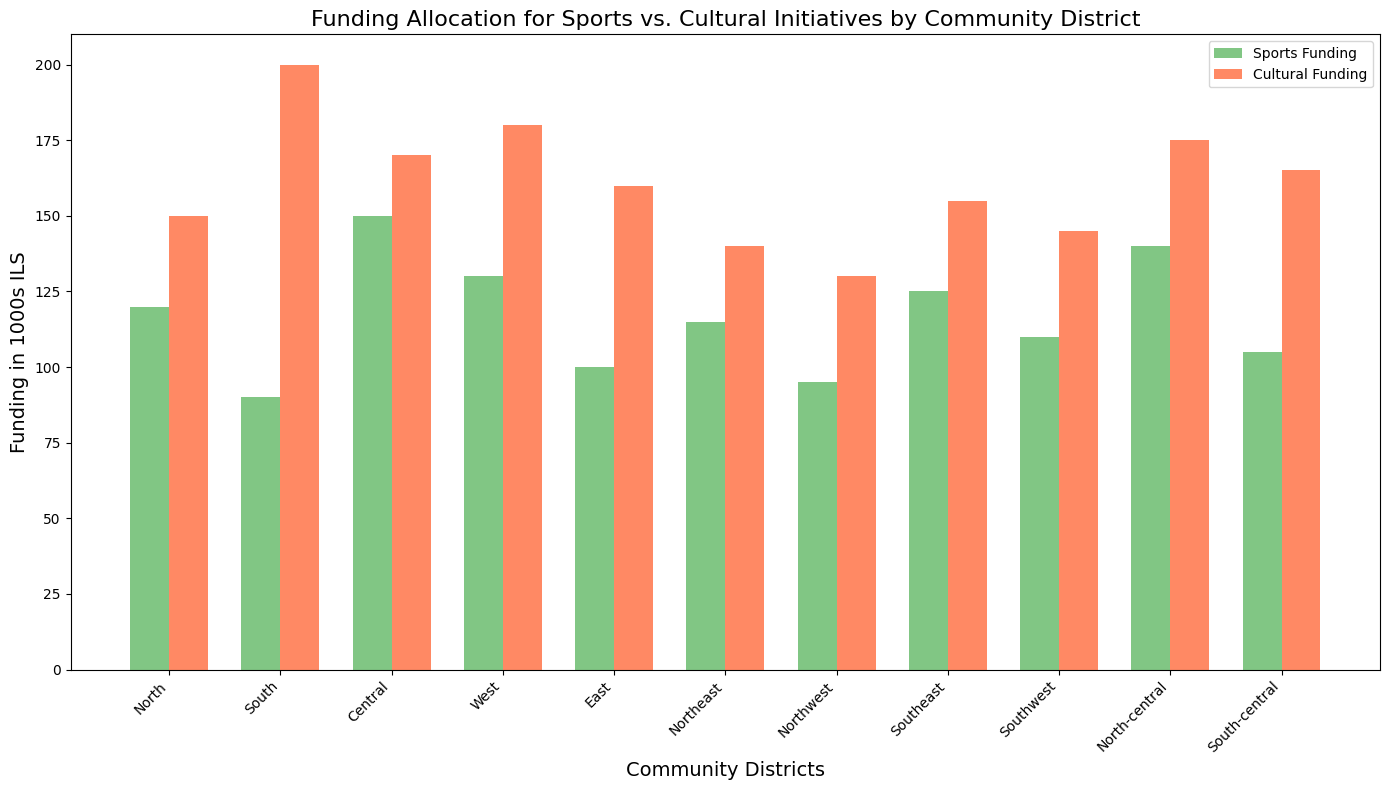Which community district received the highest total funding? To find out which district had the highest total funding, we need to sum the sports and cultural funding for each district. Calculating these, we get:
North (120 + 150 = 270),
South (90 + 200 = 290),
Central (150 + 170 = 320),
West (130 + 180 = 310),
East (100 + 160 = 260),
Northeast (115 + 140 = 255),
Northwest (95 + 130 = 225),
Southeast (125 + 155 = 280),
Southwest (110 + 145 = 255),
North-central (140 + 175 = 315),
South-central (105 + 165 = 270). 
The Central district received the highest total funding, 320.
Answer: Central Which districts received more cultural funding than sports funding? To answer this, we compare the cultural funding with sports funding for each district:
North (150 > 120),
South (200 > 90),
Central (170 > 150),
West (180 > 130),
East (160 > 100), 
Northeast (140 > 115),
Northwest (130 > 95),
Southeast (155 > 125),
Southwest (145 > 110),
North-central (175 > 140),
South-central (165 > 105). 
All districts received more cultural funding than sports funding.
Answer: All districts What is the average cultural funding across all districts? We sum up the cultural funding across all the districts and then divide by the number of districts which is 11. So, adding them up: 150 + 200 + 170 + 180 + 160 + 140 + 130 + 155 + 145 + 175 + 165 = 1870. 
Dividing by 11 gives 1870 / 11 = 170.
Answer: 170 Which two districts have a combined cultural funding exactly equal to 320? First, identify pairs of districts and sum their cultural funding until we find the pair that sums to 320: 
North (150) + South-central (165) = 315 (not 320),
North (150) + South (200) = 350 (not 320),
Central (170) + Northwest (130) = 300 (not 320),
West (180) + Northeast (140) = 320.
The districts that sum to 320 are West (180) and Northeast (140).
Answer: West and Northeast Which district received the lowest cultural funding? Looking at the cultural funding amounts for each district:
North (150),
South (200),
Central (170),
West (180),
East (160),
Northeast (140),
Northwest (130), 
Southeast (155),
Southwest (145),
North-central (175),
South-central (165). 
The Northwest district received the lowest cultural funding of 130.
Answer: Northwest 